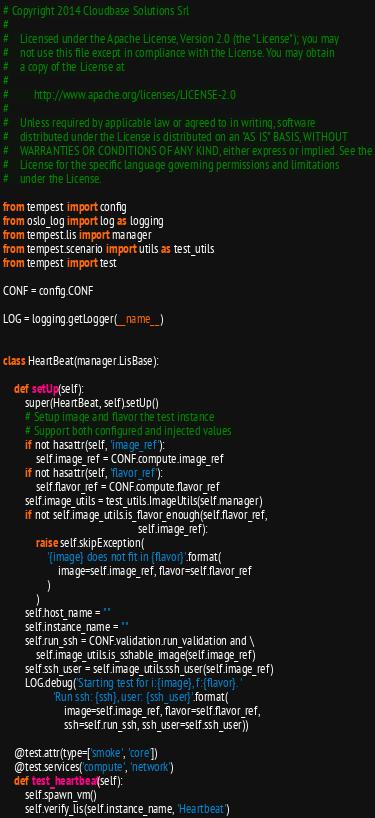Convert code to text. <code><loc_0><loc_0><loc_500><loc_500><_Python_># Copyright 2014 Cloudbase Solutions Srl
#
#    Licensed under the Apache License, Version 2.0 (the "License"); you may
#    not use this file except in compliance with the License. You may obtain
#    a copy of the License at
#
#         http://www.apache.org/licenses/LICENSE-2.0
#
#    Unless required by applicable law or agreed to in writing, software
#    distributed under the License is distributed on an "AS IS" BASIS, WITHOUT
#    WARRANTIES OR CONDITIONS OF ANY KIND, either express or implied. See the
#    License for the specific language governing permissions and limitations
#    under the License.

from tempest import config
from oslo_log import log as logging
from tempest.lis import manager
from tempest.scenario import utils as test_utils
from tempest import test

CONF = config.CONF

LOG = logging.getLogger(__name__)


class HeartBeat(manager.LisBase):

    def setUp(self):
        super(HeartBeat, self).setUp()
        # Setup image and flavor the test instance
        # Support both configured and injected values
        if not hasattr(self, 'image_ref'):
            self.image_ref = CONF.compute.image_ref
        if not hasattr(self, 'flavor_ref'):
            self.flavor_ref = CONF.compute.flavor_ref
        self.image_utils = test_utils.ImageUtils(self.manager)
        if not self.image_utils.is_flavor_enough(self.flavor_ref,
                                                 self.image_ref):
            raise self.skipException(
                '{image} does not fit in {flavor}'.format(
                    image=self.image_ref, flavor=self.flavor_ref
                )
            )
        self.host_name = ""
        self.instance_name = ""
        self.run_ssh = CONF.validation.run_validation and \
            self.image_utils.is_sshable_image(self.image_ref)
        self.ssh_user = self.image_utils.ssh_user(self.image_ref)
        LOG.debug('Starting test for i:{image}, f:{flavor}. '
                  'Run ssh: {ssh}, user: {ssh_user}'.format(
                      image=self.image_ref, flavor=self.flavor_ref,
                      ssh=self.run_ssh, ssh_user=self.ssh_user))

    @test.attr(type=['smoke', 'core'])
    @test.services('compute', 'network')
    def test_heartbeat(self):
        self.spawn_vm()
        self.verify_lis(self.instance_name, 'Heartbeat')</code> 